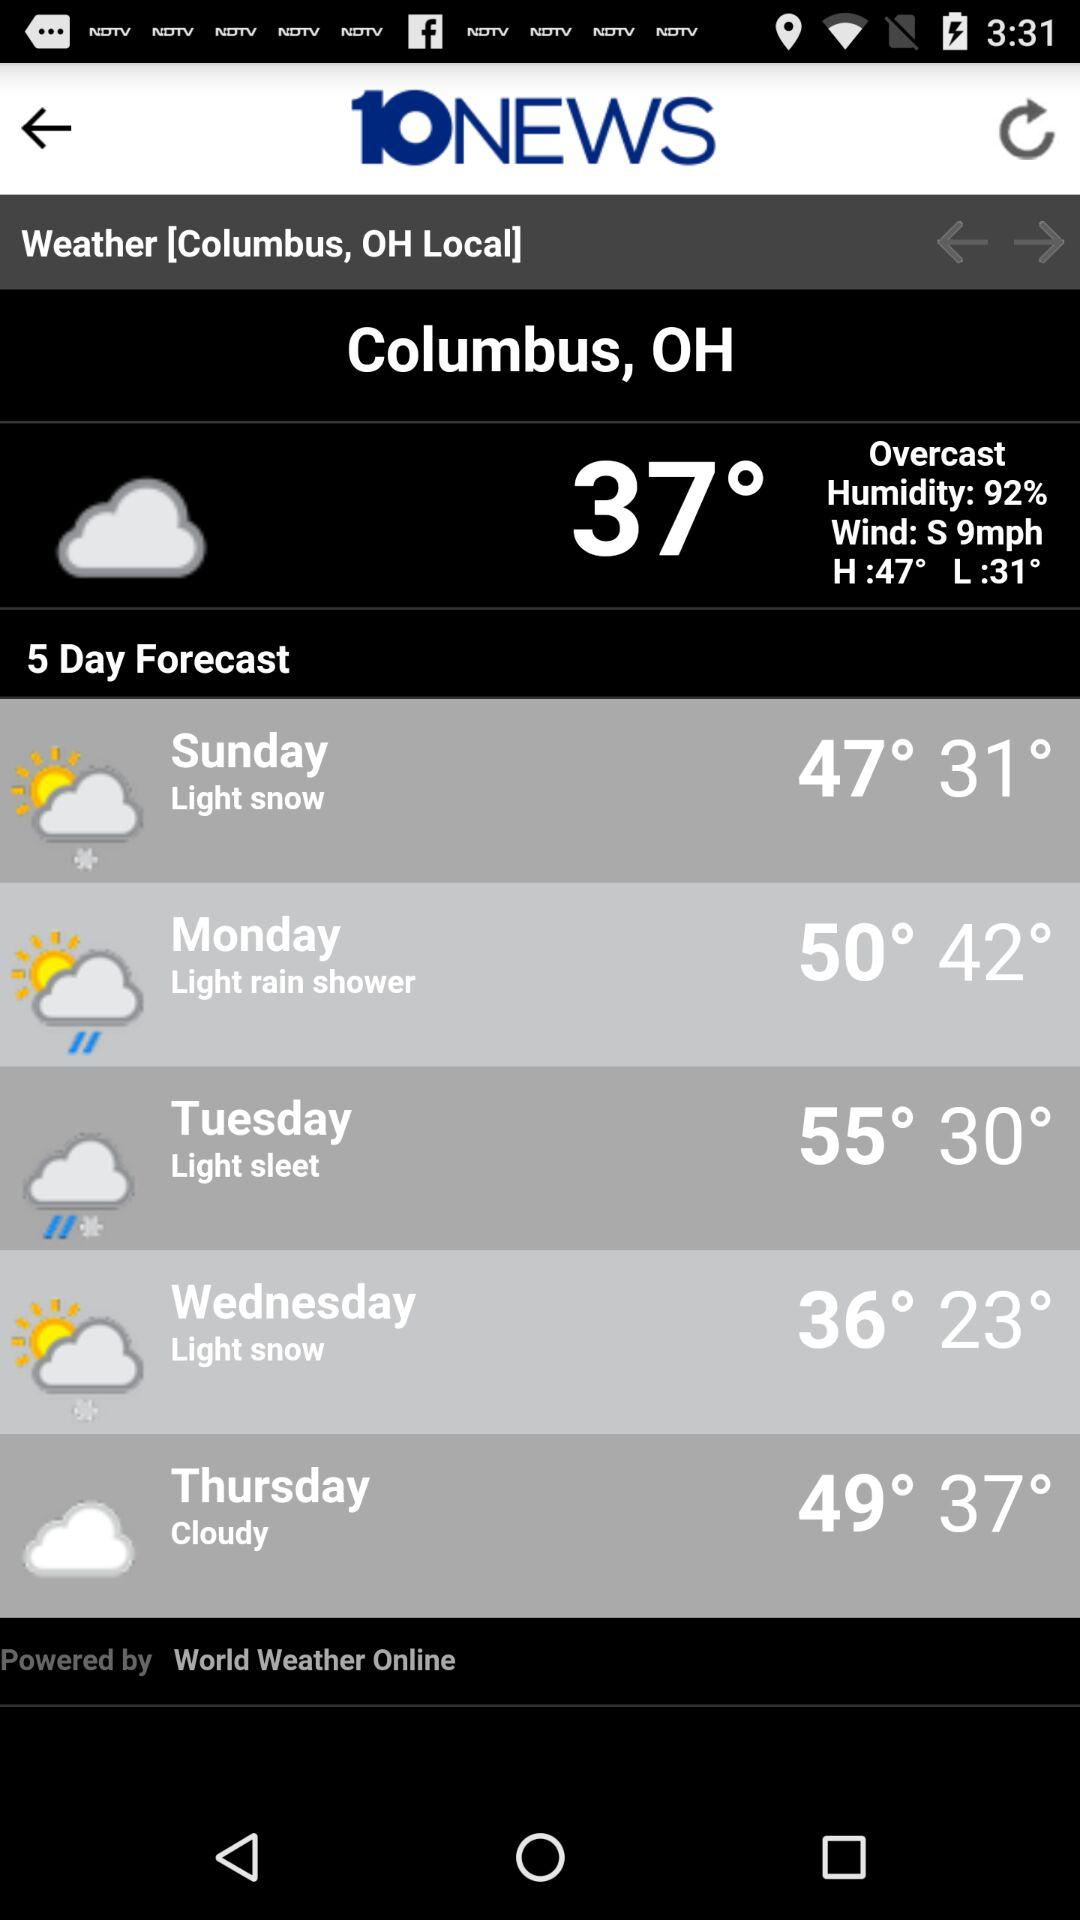What is the high temperature for Tuesday? The high temperature for Tuesday is expected to be 55 degrees Fahrenheit. 